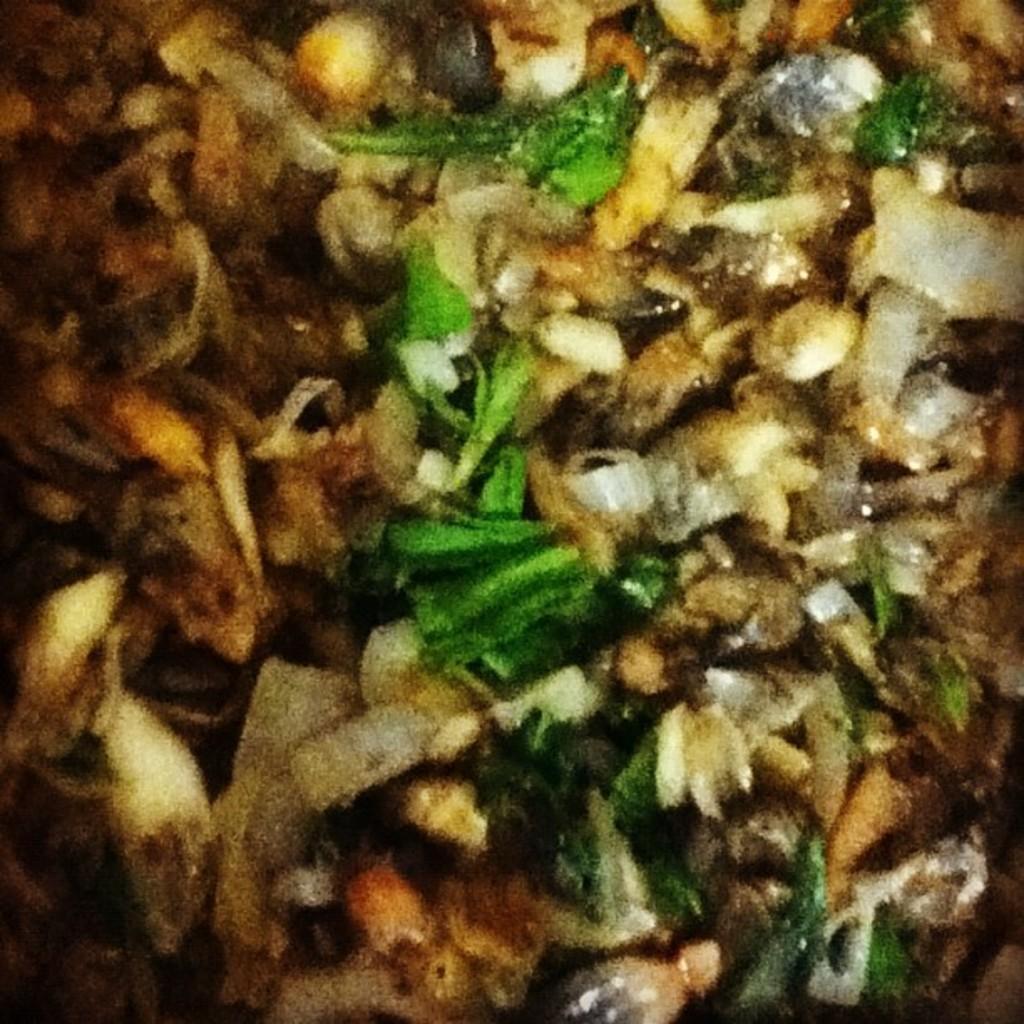In one or two sentences, can you explain what this image depicts? In this picture we can see food. 